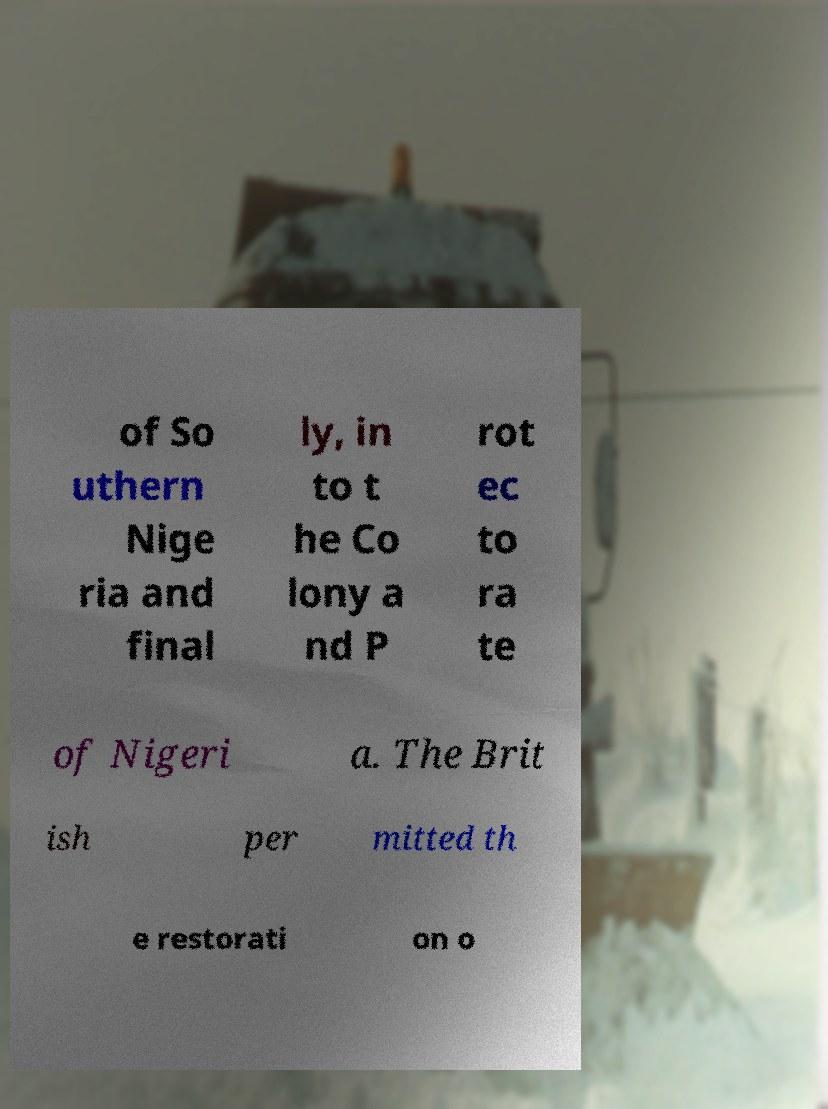Please read and relay the text visible in this image. What does it say? of So uthern Nige ria and final ly, in to t he Co lony a nd P rot ec to ra te of Nigeri a. The Brit ish per mitted th e restorati on o 